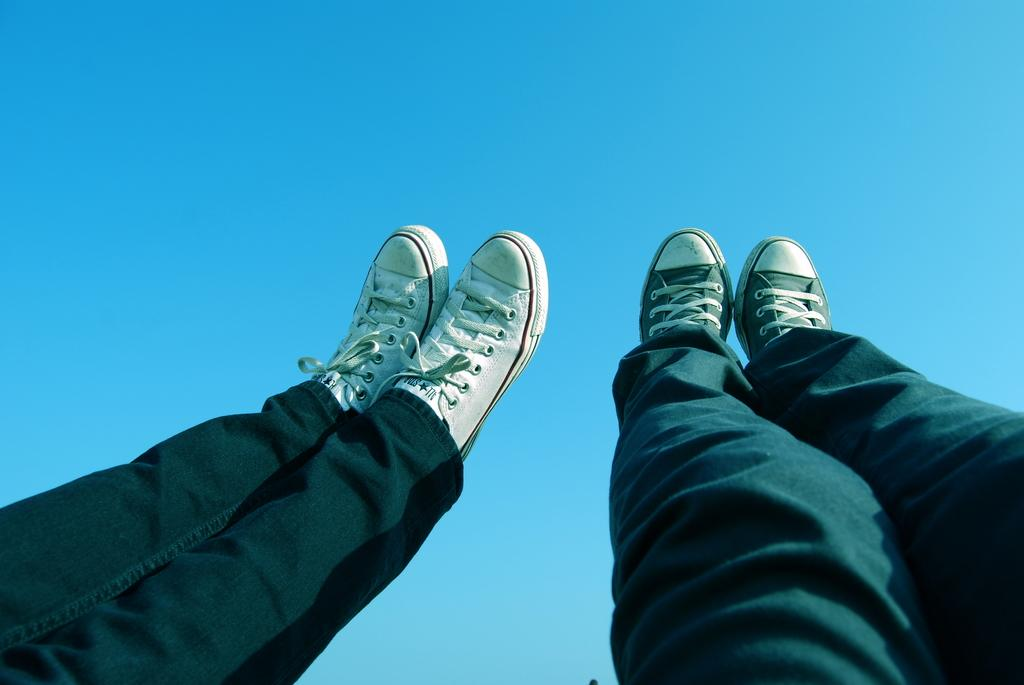How many persons are present in the image? There are two persons in the image, as indicated by the presence of their legs. What type of footwear are the persons wearing? The persons are wearing shoes. What can be seen in the background of the image? The sky is visible in the background of the image. What type of quill can be seen in the image? There is no quill present in the image. What boundary is visible in the image? There is no boundary visible in the image. 